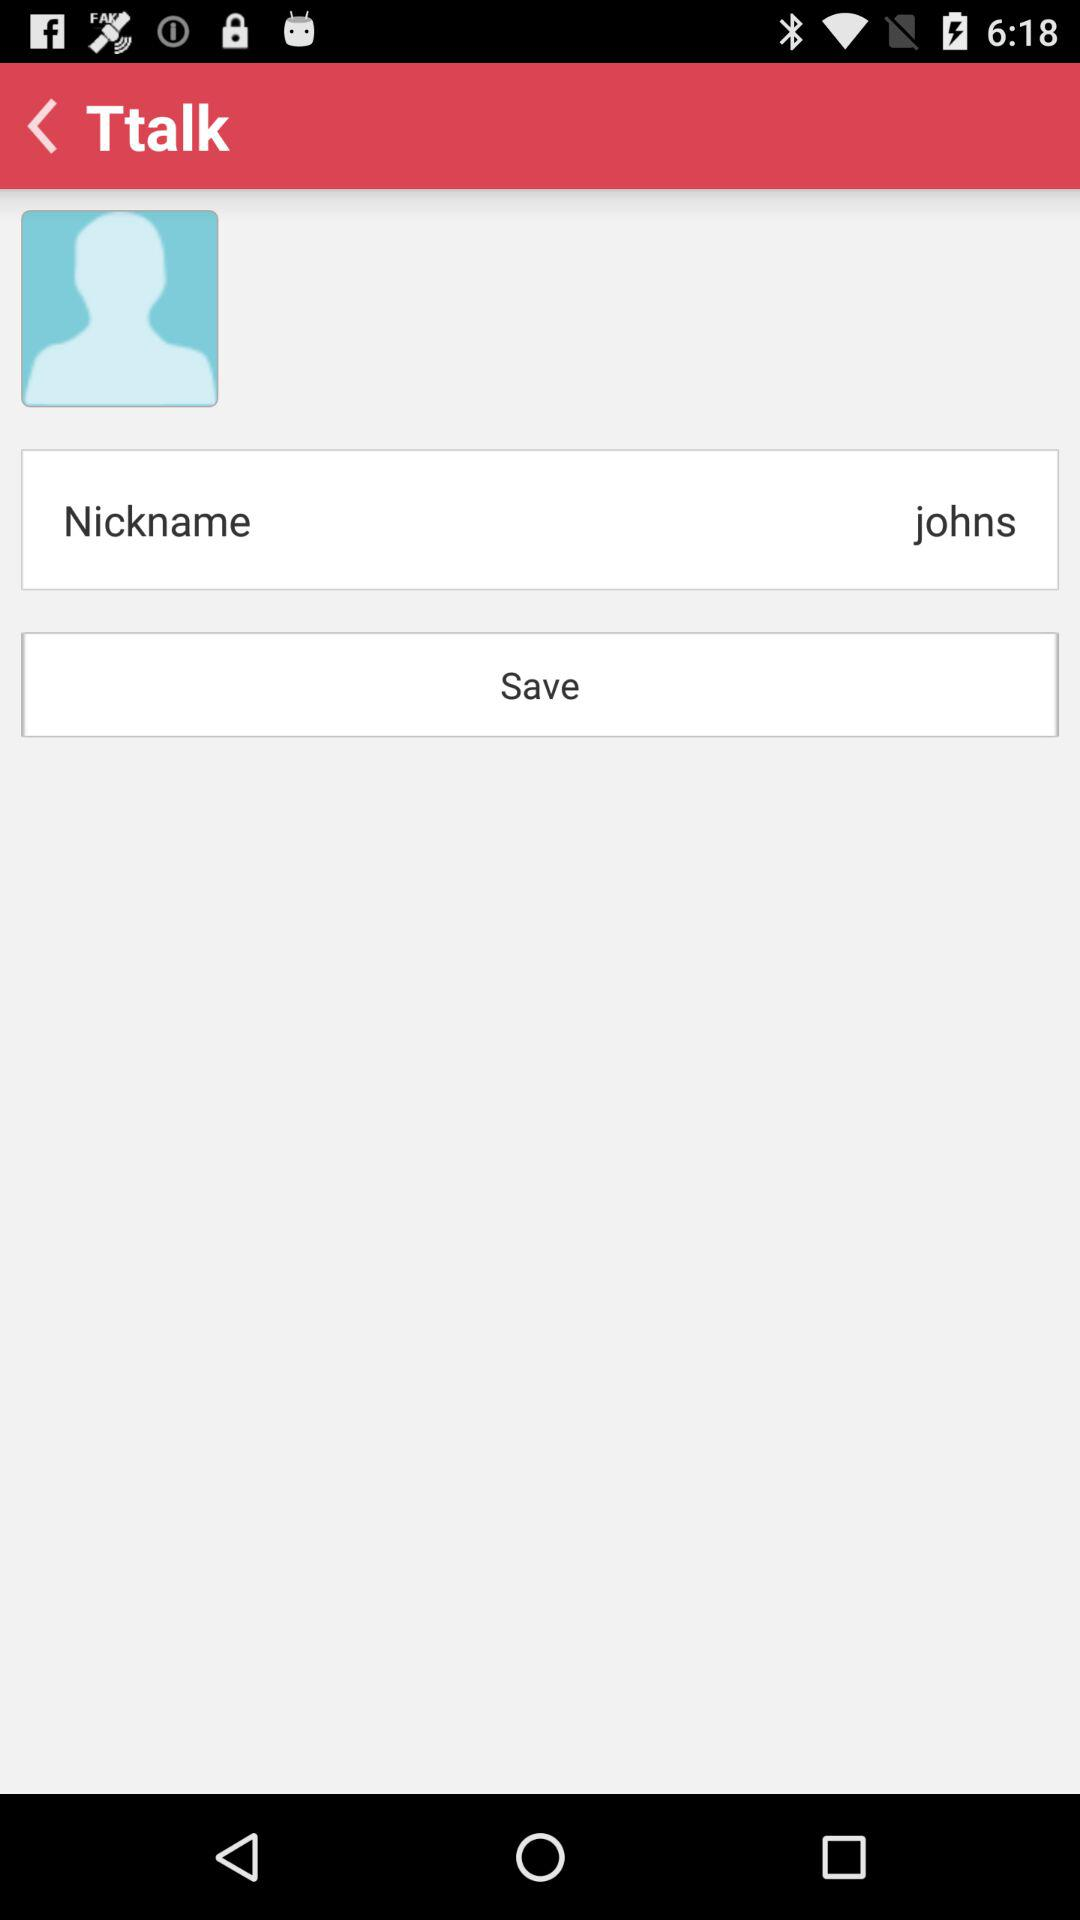What is the nickname? The nickname is johns. 